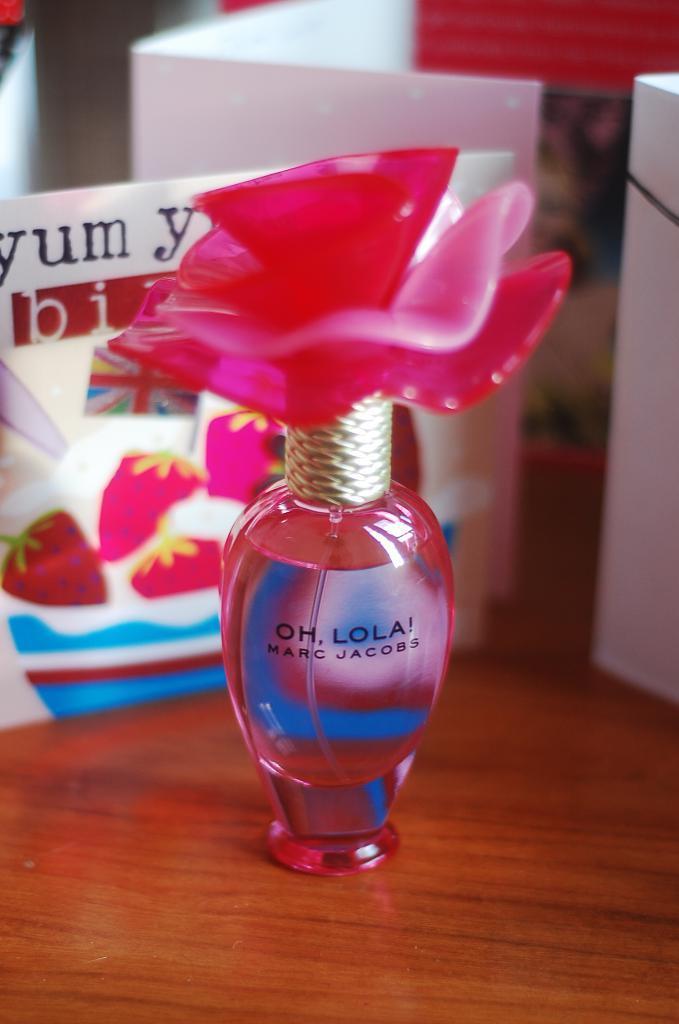<image>
Summarize the visual content of the image. an Oh Lola scent that has a brown desk under it 